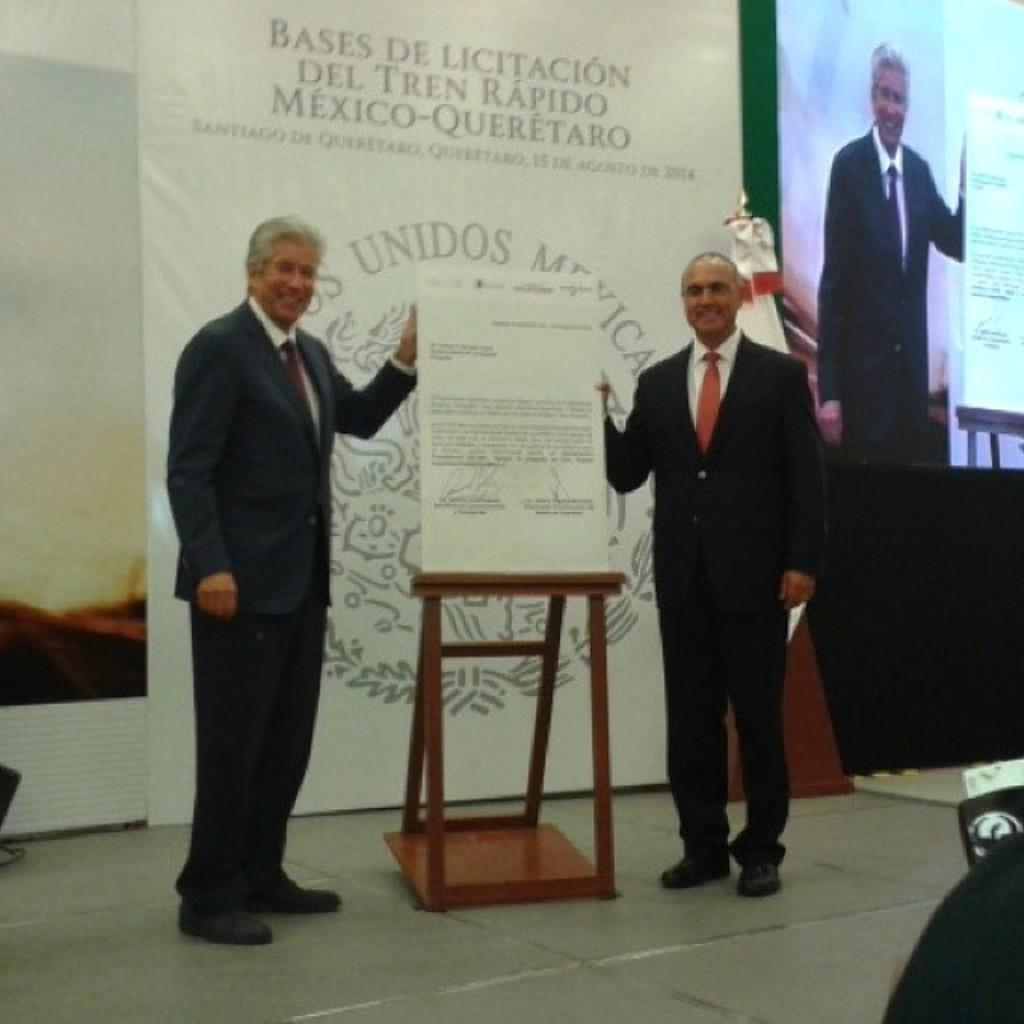How many people are in the image? There are two men in the image. What are the men doing in the image? The men are standing and holding a paper. What can be seen in the background of the image? There is a screen and a banner in the background of the image. What expressions do the men have on their faces? The men have smiles on their faces. What type of harbor can be seen in the image? There is no harbor present in the image. What color are the men's eyes in the image? The image does not show the men's eyes, so it is not possible to determine their color. 